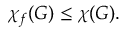<formula> <loc_0><loc_0><loc_500><loc_500>\chi _ { f } ( G ) \leq \chi ( G ) .</formula> 